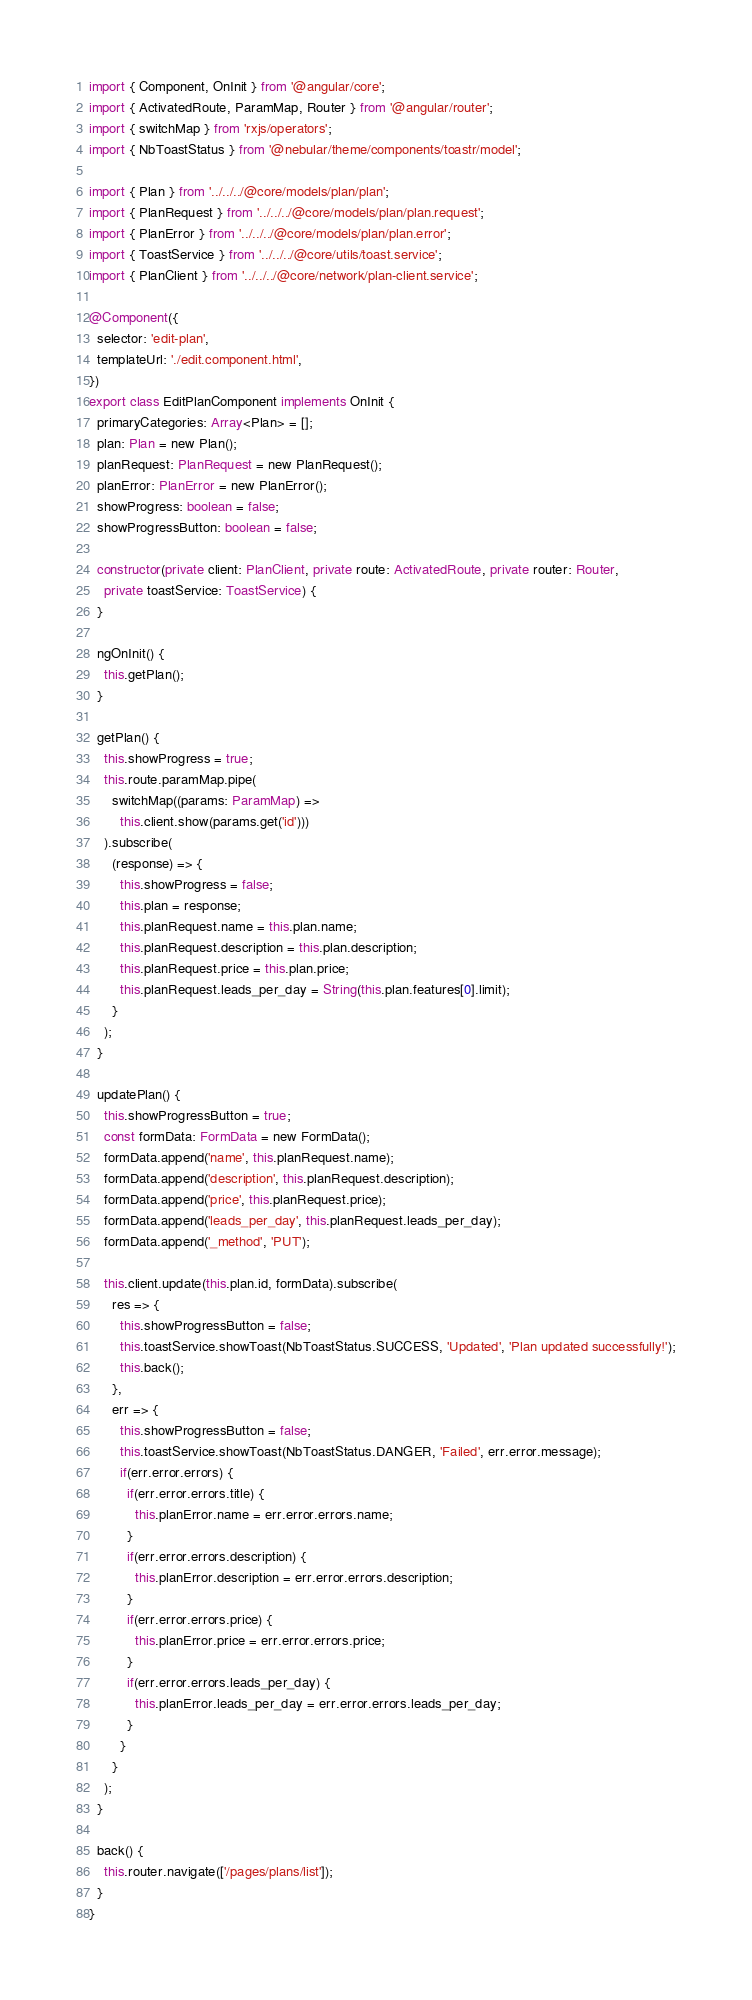Convert code to text. <code><loc_0><loc_0><loc_500><loc_500><_TypeScript_>import { Component, OnInit } from '@angular/core';
import { ActivatedRoute, ParamMap, Router } from '@angular/router';
import { switchMap } from 'rxjs/operators';
import { NbToastStatus } from '@nebular/theme/components/toastr/model';

import { Plan } from '../../../@core/models/plan/plan';
import { PlanRequest } from '../../../@core/models/plan/plan.request';
import { PlanError } from '../../../@core/models/plan/plan.error';
import { ToastService } from '../../../@core/utils/toast.service';
import { PlanClient } from '../../../@core/network/plan-client.service';

@Component({
  selector: 'edit-plan',  
  templateUrl: './edit.component.html',
})
export class EditPlanComponent implements OnInit {
  primaryCategories: Array<Plan> = [];
  plan: Plan = new Plan();
  planRequest: PlanRequest = new PlanRequest();
  planError: PlanError = new PlanError();  
  showProgress: boolean = false;
  showProgressButton: boolean = false;

  constructor(private client: PlanClient, private route: ActivatedRoute, private router: Router,
    private toastService: ToastService) {    
  }

  ngOnInit() {
    this.getPlan();
  }

  getPlan() {
    this.showProgress = true;
    this.route.paramMap.pipe(
      switchMap((params: ParamMap) =>
        this.client.show(params.get('id')))
    ).subscribe(
      (response) => {
        this.showProgress = false;
        this.plan = response;
        this.planRequest.name = this.plan.name;        
        this.planRequest.description = this.plan.description;        
        this.planRequest.price = this.plan.price;        
        this.planRequest.leads_per_day = String(this.plan.features[0].limit);
      }
    );
  }

  updatePlan() {
    this.showProgressButton = true;
    const formData: FormData = new FormData();
    formData.append('name', this.planRequest.name);
    formData.append('description', this.planRequest.description);
    formData.append('price', this.planRequest.price);
    formData.append('leads_per_day', this.planRequest.leads_per_day);
    formData.append('_method', 'PUT');

    this.client.update(this.plan.id, formData).subscribe(
      res => {
        this.showProgressButton = false;
        this.toastService.showToast(NbToastStatus.SUCCESS, 'Updated', 'Plan updated successfully!');
        this.back();
      },
      err => {        
        this.showProgressButton = false;
        this.toastService.showToast(NbToastStatus.DANGER, 'Failed', err.error.message);
        if(err.error.errors) {
          if(err.error.errors.title) {
            this.planError.name = err.error.errors.name;
          }
          if(err.error.errors.description) {
            this.planError.description = err.error.errors.description;
          }
          if(err.error.errors.price) {
            this.planError.price = err.error.errors.price;
          }
          if(err.error.errors.leads_per_day) {
            this.planError.leads_per_day = err.error.errors.leads_per_day;
          }
        }
      }
    );
  }

  back() {
    this.router.navigate(['/pages/plans/list']);
  }
}
</code> 